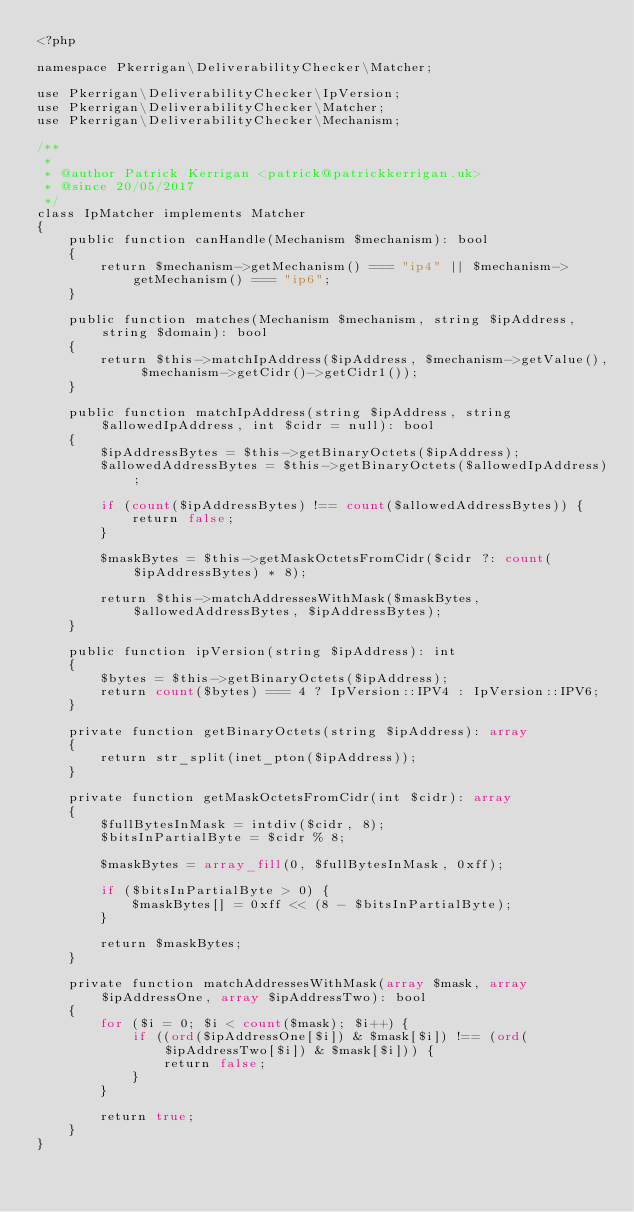Convert code to text. <code><loc_0><loc_0><loc_500><loc_500><_PHP_><?php

namespace Pkerrigan\DeliverabilityChecker\Matcher;

use Pkerrigan\DeliverabilityChecker\IpVersion;
use Pkerrigan\DeliverabilityChecker\Matcher;
use Pkerrigan\DeliverabilityChecker\Mechanism;

/**
 *
 * @author Patrick Kerrigan <patrick@patrickkerrigan.uk>
 * @since 20/05/2017
 */
class IpMatcher implements Matcher
{
    public function canHandle(Mechanism $mechanism): bool
    {
        return $mechanism->getMechanism() === "ip4" || $mechanism->getMechanism() === "ip6";
    }

    public function matches(Mechanism $mechanism, string $ipAddress, string $domain): bool
    {
        return $this->matchIpAddress($ipAddress, $mechanism->getValue(), $mechanism->getCidr()->getCidr1());
    }

    public function matchIpAddress(string $ipAddress, string $allowedIpAddress, int $cidr = null): bool
    {
        $ipAddressBytes = $this->getBinaryOctets($ipAddress);
        $allowedAddressBytes = $this->getBinaryOctets($allowedIpAddress);

        if (count($ipAddressBytes) !== count($allowedAddressBytes)) {
            return false;
        }

        $maskBytes = $this->getMaskOctetsFromCidr($cidr ?: count($ipAddressBytes) * 8);

        return $this->matchAddressesWithMask($maskBytes, $allowedAddressBytes, $ipAddressBytes);
    }

    public function ipVersion(string $ipAddress): int
    {
        $bytes = $this->getBinaryOctets($ipAddress);
        return count($bytes) === 4 ? IpVersion::IPV4 : IpVersion::IPV6;
    }

    private function getBinaryOctets(string $ipAddress): array
    {
        return str_split(inet_pton($ipAddress));
    }

    private function getMaskOctetsFromCidr(int $cidr): array
    {
        $fullBytesInMask = intdiv($cidr, 8);
        $bitsInPartialByte = $cidr % 8;

        $maskBytes = array_fill(0, $fullBytesInMask, 0xff);

        if ($bitsInPartialByte > 0) {
            $maskBytes[] = 0xff << (8 - $bitsInPartialByte);
        }

        return $maskBytes;
    }

    private function matchAddressesWithMask(array $mask, array $ipAddressOne, array $ipAddressTwo): bool
    {
        for ($i = 0; $i < count($mask); $i++) {
            if ((ord($ipAddressOne[$i]) & $mask[$i]) !== (ord($ipAddressTwo[$i]) & $mask[$i])) {
                return false;
            }
        }

        return true;
    }
}
</code> 